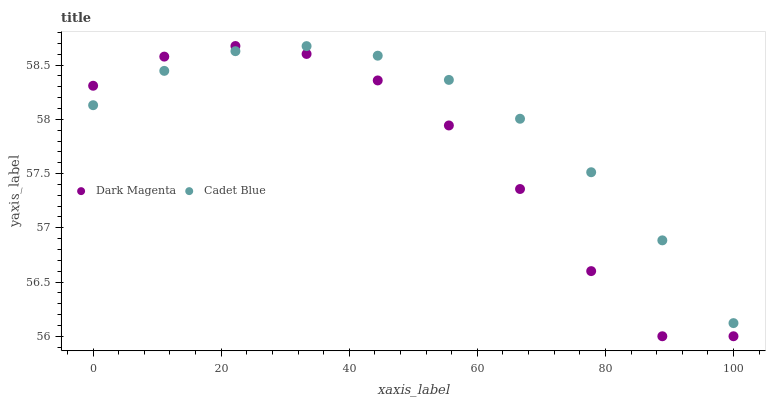Does Dark Magenta have the minimum area under the curve?
Answer yes or no. Yes. Does Cadet Blue have the maximum area under the curve?
Answer yes or no. Yes. Does Dark Magenta have the maximum area under the curve?
Answer yes or no. No. Is Cadet Blue the smoothest?
Answer yes or no. Yes. Is Dark Magenta the roughest?
Answer yes or no. Yes. Is Dark Magenta the smoothest?
Answer yes or no. No. Does Dark Magenta have the lowest value?
Answer yes or no. Yes. Does Dark Magenta have the highest value?
Answer yes or no. Yes. Does Cadet Blue intersect Dark Magenta?
Answer yes or no. Yes. Is Cadet Blue less than Dark Magenta?
Answer yes or no. No. Is Cadet Blue greater than Dark Magenta?
Answer yes or no. No. 